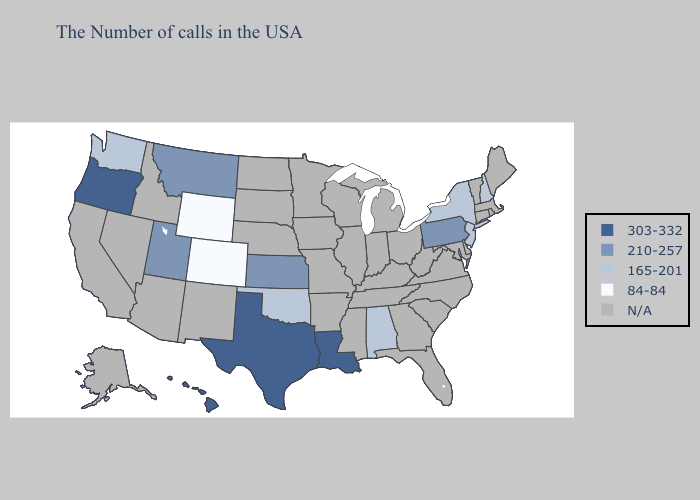What is the value of Florida?
Quick response, please. N/A. Does Hawaii have the highest value in the USA?
Be succinct. Yes. Does Washington have the lowest value in the West?
Quick response, please. No. What is the lowest value in the South?
Answer briefly. 165-201. What is the value of North Dakota?
Quick response, please. N/A. Among the states that border Nevada , which have the lowest value?
Quick response, please. Utah. What is the value of Delaware?
Keep it brief. N/A. What is the value of Kansas?
Answer briefly. 210-257. Does Colorado have the lowest value in the USA?
Quick response, please. Yes. Name the states that have a value in the range 84-84?
Quick response, please. Wyoming, Colorado. What is the value of Delaware?
Be succinct. N/A. What is the highest value in the South ?
Keep it brief. 303-332. Among the states that border Kansas , does Oklahoma have the lowest value?
Keep it brief. No. 